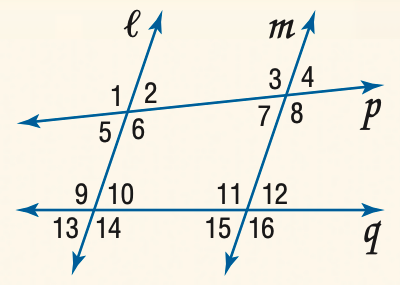Answer the mathemtical geometry problem and directly provide the correct option letter.
Question: Find the measure of \angle 4 if l \parallel m and m \angle 1 = 105.
Choices: A: 75 B: 85 C: 95 D: 105 A 